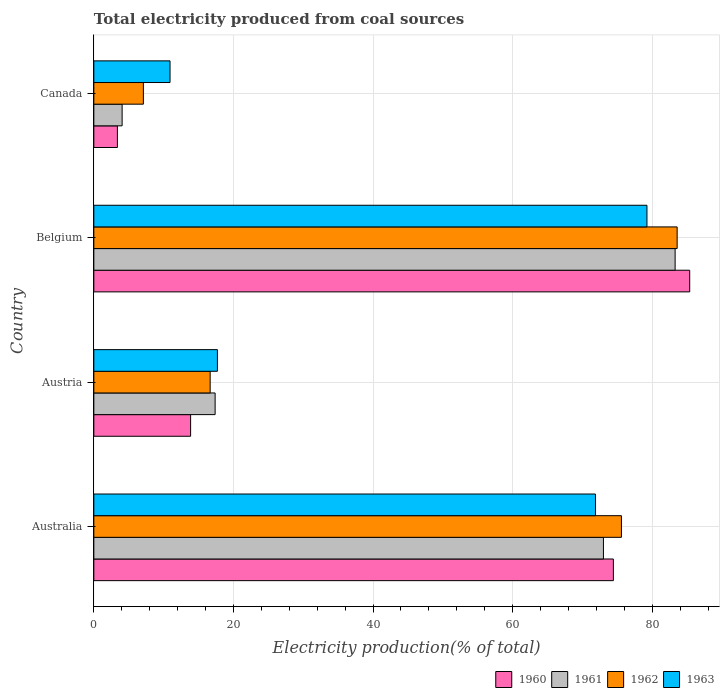How many groups of bars are there?
Your answer should be compact. 4. How many bars are there on the 2nd tick from the bottom?
Offer a very short reply. 4. What is the total electricity produced in 1963 in Australia?
Offer a very short reply. 71.86. Across all countries, what is the maximum total electricity produced in 1961?
Your response must be concise. 83.27. Across all countries, what is the minimum total electricity produced in 1963?
Your response must be concise. 10.92. In which country was the total electricity produced in 1962 minimum?
Keep it short and to the point. Canada. What is the total total electricity produced in 1962 in the graph?
Make the answer very short. 182.9. What is the difference between the total electricity produced in 1961 in Austria and that in Canada?
Provide a succinct answer. 13.32. What is the difference between the total electricity produced in 1963 in Austria and the total electricity produced in 1961 in Canada?
Your answer should be compact. 13.65. What is the average total electricity produced in 1961 per country?
Offer a very short reply. 44.42. What is the difference between the total electricity produced in 1961 and total electricity produced in 1963 in Austria?
Offer a very short reply. -0.33. In how many countries, is the total electricity produced in 1960 greater than 48 %?
Give a very brief answer. 2. What is the ratio of the total electricity produced in 1963 in Belgium to that in Canada?
Ensure brevity in your answer.  7.26. Is the total electricity produced in 1963 in Australia less than that in Canada?
Give a very brief answer. No. Is the difference between the total electricity produced in 1961 in Australia and Canada greater than the difference between the total electricity produced in 1963 in Australia and Canada?
Provide a short and direct response. Yes. What is the difference between the highest and the second highest total electricity produced in 1962?
Offer a terse response. 7.98. What is the difference between the highest and the lowest total electricity produced in 1962?
Provide a succinct answer. 76.46. Is it the case that in every country, the sum of the total electricity produced in 1960 and total electricity produced in 1963 is greater than the sum of total electricity produced in 1961 and total electricity produced in 1962?
Offer a terse response. No. What does the 2nd bar from the top in Australia represents?
Make the answer very short. 1962. What does the 2nd bar from the bottom in Canada represents?
Give a very brief answer. 1961. Is it the case that in every country, the sum of the total electricity produced in 1960 and total electricity produced in 1963 is greater than the total electricity produced in 1961?
Offer a very short reply. Yes. Are all the bars in the graph horizontal?
Offer a terse response. Yes. What is the difference between two consecutive major ticks on the X-axis?
Give a very brief answer. 20. Does the graph contain any zero values?
Your response must be concise. No. Does the graph contain grids?
Provide a succinct answer. Yes. How many legend labels are there?
Ensure brevity in your answer.  4. How are the legend labels stacked?
Provide a short and direct response. Horizontal. What is the title of the graph?
Ensure brevity in your answer.  Total electricity produced from coal sources. Does "2009" appear as one of the legend labels in the graph?
Offer a terse response. No. What is the label or title of the X-axis?
Provide a succinct answer. Electricity production(% of total). What is the label or title of the Y-axis?
Provide a short and direct response. Country. What is the Electricity production(% of total) in 1960 in Australia?
Your answer should be compact. 74.42. What is the Electricity production(% of total) in 1961 in Australia?
Your response must be concise. 73. What is the Electricity production(% of total) of 1962 in Australia?
Your answer should be very brief. 75.58. What is the Electricity production(% of total) of 1963 in Australia?
Ensure brevity in your answer.  71.86. What is the Electricity production(% of total) in 1960 in Austria?
Your answer should be compact. 13.86. What is the Electricity production(% of total) of 1961 in Austria?
Keep it short and to the point. 17.38. What is the Electricity production(% of total) of 1962 in Austria?
Ensure brevity in your answer.  16.66. What is the Electricity production(% of total) in 1963 in Austria?
Make the answer very short. 17.7. What is the Electricity production(% of total) in 1960 in Belgium?
Your response must be concise. 85.36. What is the Electricity production(% of total) in 1961 in Belgium?
Your answer should be compact. 83.27. What is the Electricity production(% of total) of 1962 in Belgium?
Provide a succinct answer. 83.56. What is the Electricity production(% of total) in 1963 in Belgium?
Your answer should be compact. 79.23. What is the Electricity production(% of total) in 1960 in Canada?
Ensure brevity in your answer.  3.38. What is the Electricity production(% of total) of 1961 in Canada?
Provide a succinct answer. 4.05. What is the Electricity production(% of total) in 1962 in Canada?
Your answer should be very brief. 7.1. What is the Electricity production(% of total) of 1963 in Canada?
Offer a terse response. 10.92. Across all countries, what is the maximum Electricity production(% of total) in 1960?
Provide a short and direct response. 85.36. Across all countries, what is the maximum Electricity production(% of total) in 1961?
Provide a succinct answer. 83.27. Across all countries, what is the maximum Electricity production(% of total) in 1962?
Your response must be concise. 83.56. Across all countries, what is the maximum Electricity production(% of total) of 1963?
Make the answer very short. 79.23. Across all countries, what is the minimum Electricity production(% of total) in 1960?
Ensure brevity in your answer.  3.38. Across all countries, what is the minimum Electricity production(% of total) of 1961?
Make the answer very short. 4.05. Across all countries, what is the minimum Electricity production(% of total) of 1962?
Keep it short and to the point. 7.1. Across all countries, what is the minimum Electricity production(% of total) in 1963?
Your answer should be very brief. 10.92. What is the total Electricity production(% of total) in 1960 in the graph?
Give a very brief answer. 177.02. What is the total Electricity production(% of total) in 1961 in the graph?
Your answer should be very brief. 177.7. What is the total Electricity production(% of total) in 1962 in the graph?
Offer a very short reply. 182.9. What is the total Electricity production(% of total) of 1963 in the graph?
Ensure brevity in your answer.  179.71. What is the difference between the Electricity production(% of total) of 1960 in Australia and that in Austria?
Offer a terse response. 60.56. What is the difference between the Electricity production(% of total) of 1961 in Australia and that in Austria?
Keep it short and to the point. 55.62. What is the difference between the Electricity production(% of total) in 1962 in Australia and that in Austria?
Give a very brief answer. 58.91. What is the difference between the Electricity production(% of total) of 1963 in Australia and that in Austria?
Make the answer very short. 54.16. What is the difference between the Electricity production(% of total) in 1960 in Australia and that in Belgium?
Your response must be concise. -10.93. What is the difference between the Electricity production(% of total) of 1961 in Australia and that in Belgium?
Your answer should be very brief. -10.27. What is the difference between the Electricity production(% of total) in 1962 in Australia and that in Belgium?
Ensure brevity in your answer.  -7.98. What is the difference between the Electricity production(% of total) in 1963 in Australia and that in Belgium?
Give a very brief answer. -7.37. What is the difference between the Electricity production(% of total) in 1960 in Australia and that in Canada?
Your response must be concise. 71.05. What is the difference between the Electricity production(% of total) in 1961 in Australia and that in Canada?
Give a very brief answer. 68.94. What is the difference between the Electricity production(% of total) of 1962 in Australia and that in Canada?
Your answer should be very brief. 68.48. What is the difference between the Electricity production(% of total) in 1963 in Australia and that in Canada?
Provide a succinct answer. 60.94. What is the difference between the Electricity production(% of total) of 1960 in Austria and that in Belgium?
Provide a succinct answer. -71.49. What is the difference between the Electricity production(% of total) in 1961 in Austria and that in Belgium?
Offer a very short reply. -65.89. What is the difference between the Electricity production(% of total) in 1962 in Austria and that in Belgium?
Your answer should be very brief. -66.89. What is the difference between the Electricity production(% of total) in 1963 in Austria and that in Belgium?
Offer a terse response. -61.53. What is the difference between the Electricity production(% of total) in 1960 in Austria and that in Canada?
Your answer should be very brief. 10.49. What is the difference between the Electricity production(% of total) of 1961 in Austria and that in Canada?
Provide a succinct answer. 13.32. What is the difference between the Electricity production(% of total) of 1962 in Austria and that in Canada?
Give a very brief answer. 9.57. What is the difference between the Electricity production(% of total) of 1963 in Austria and that in Canada?
Keep it short and to the point. 6.79. What is the difference between the Electricity production(% of total) of 1960 in Belgium and that in Canada?
Your response must be concise. 81.98. What is the difference between the Electricity production(% of total) in 1961 in Belgium and that in Canada?
Offer a very short reply. 79.21. What is the difference between the Electricity production(% of total) of 1962 in Belgium and that in Canada?
Make the answer very short. 76.46. What is the difference between the Electricity production(% of total) in 1963 in Belgium and that in Canada?
Your answer should be very brief. 68.31. What is the difference between the Electricity production(% of total) of 1960 in Australia and the Electricity production(% of total) of 1961 in Austria?
Ensure brevity in your answer.  57.05. What is the difference between the Electricity production(% of total) of 1960 in Australia and the Electricity production(% of total) of 1962 in Austria?
Ensure brevity in your answer.  57.76. What is the difference between the Electricity production(% of total) in 1960 in Australia and the Electricity production(% of total) in 1963 in Austria?
Your answer should be very brief. 56.72. What is the difference between the Electricity production(% of total) of 1961 in Australia and the Electricity production(% of total) of 1962 in Austria?
Your response must be concise. 56.33. What is the difference between the Electricity production(% of total) of 1961 in Australia and the Electricity production(% of total) of 1963 in Austria?
Keep it short and to the point. 55.3. What is the difference between the Electricity production(% of total) in 1962 in Australia and the Electricity production(% of total) in 1963 in Austria?
Give a very brief answer. 57.87. What is the difference between the Electricity production(% of total) in 1960 in Australia and the Electricity production(% of total) in 1961 in Belgium?
Make the answer very short. -8.84. What is the difference between the Electricity production(% of total) in 1960 in Australia and the Electricity production(% of total) in 1962 in Belgium?
Offer a terse response. -9.13. What is the difference between the Electricity production(% of total) in 1960 in Australia and the Electricity production(% of total) in 1963 in Belgium?
Offer a very short reply. -4.81. What is the difference between the Electricity production(% of total) of 1961 in Australia and the Electricity production(% of total) of 1962 in Belgium?
Provide a succinct answer. -10.56. What is the difference between the Electricity production(% of total) in 1961 in Australia and the Electricity production(% of total) in 1963 in Belgium?
Provide a succinct answer. -6.23. What is the difference between the Electricity production(% of total) of 1962 in Australia and the Electricity production(% of total) of 1963 in Belgium?
Give a very brief answer. -3.66. What is the difference between the Electricity production(% of total) in 1960 in Australia and the Electricity production(% of total) in 1961 in Canada?
Give a very brief answer. 70.37. What is the difference between the Electricity production(% of total) of 1960 in Australia and the Electricity production(% of total) of 1962 in Canada?
Provide a succinct answer. 67.32. What is the difference between the Electricity production(% of total) in 1960 in Australia and the Electricity production(% of total) in 1963 in Canada?
Your answer should be very brief. 63.51. What is the difference between the Electricity production(% of total) of 1961 in Australia and the Electricity production(% of total) of 1962 in Canada?
Your answer should be compact. 65.9. What is the difference between the Electricity production(% of total) in 1961 in Australia and the Electricity production(% of total) in 1963 in Canada?
Your answer should be compact. 62.08. What is the difference between the Electricity production(% of total) in 1962 in Australia and the Electricity production(% of total) in 1963 in Canada?
Your answer should be compact. 64.66. What is the difference between the Electricity production(% of total) of 1960 in Austria and the Electricity production(% of total) of 1961 in Belgium?
Provide a short and direct response. -69.4. What is the difference between the Electricity production(% of total) in 1960 in Austria and the Electricity production(% of total) in 1962 in Belgium?
Offer a terse response. -69.69. What is the difference between the Electricity production(% of total) of 1960 in Austria and the Electricity production(% of total) of 1963 in Belgium?
Provide a succinct answer. -65.37. What is the difference between the Electricity production(% of total) in 1961 in Austria and the Electricity production(% of total) in 1962 in Belgium?
Make the answer very short. -66.18. What is the difference between the Electricity production(% of total) of 1961 in Austria and the Electricity production(% of total) of 1963 in Belgium?
Keep it short and to the point. -61.86. What is the difference between the Electricity production(% of total) in 1962 in Austria and the Electricity production(% of total) in 1963 in Belgium?
Offer a terse response. -62.57. What is the difference between the Electricity production(% of total) of 1960 in Austria and the Electricity production(% of total) of 1961 in Canada?
Your answer should be very brief. 9.81. What is the difference between the Electricity production(% of total) in 1960 in Austria and the Electricity production(% of total) in 1962 in Canada?
Your response must be concise. 6.77. What is the difference between the Electricity production(% of total) in 1960 in Austria and the Electricity production(% of total) in 1963 in Canada?
Ensure brevity in your answer.  2.95. What is the difference between the Electricity production(% of total) of 1961 in Austria and the Electricity production(% of total) of 1962 in Canada?
Keep it short and to the point. 10.28. What is the difference between the Electricity production(% of total) in 1961 in Austria and the Electricity production(% of total) in 1963 in Canada?
Offer a terse response. 6.46. What is the difference between the Electricity production(% of total) of 1962 in Austria and the Electricity production(% of total) of 1963 in Canada?
Make the answer very short. 5.75. What is the difference between the Electricity production(% of total) of 1960 in Belgium and the Electricity production(% of total) of 1961 in Canada?
Make the answer very short. 81.3. What is the difference between the Electricity production(% of total) of 1960 in Belgium and the Electricity production(% of total) of 1962 in Canada?
Your answer should be compact. 78.26. What is the difference between the Electricity production(% of total) of 1960 in Belgium and the Electricity production(% of total) of 1963 in Canada?
Your answer should be compact. 74.44. What is the difference between the Electricity production(% of total) of 1961 in Belgium and the Electricity production(% of total) of 1962 in Canada?
Your answer should be compact. 76.17. What is the difference between the Electricity production(% of total) of 1961 in Belgium and the Electricity production(% of total) of 1963 in Canada?
Provide a short and direct response. 72.35. What is the difference between the Electricity production(% of total) in 1962 in Belgium and the Electricity production(% of total) in 1963 in Canada?
Your response must be concise. 72.64. What is the average Electricity production(% of total) of 1960 per country?
Provide a short and direct response. 44.26. What is the average Electricity production(% of total) in 1961 per country?
Provide a short and direct response. 44.42. What is the average Electricity production(% of total) in 1962 per country?
Provide a short and direct response. 45.72. What is the average Electricity production(% of total) in 1963 per country?
Provide a succinct answer. 44.93. What is the difference between the Electricity production(% of total) in 1960 and Electricity production(% of total) in 1961 in Australia?
Offer a very short reply. 1.42. What is the difference between the Electricity production(% of total) of 1960 and Electricity production(% of total) of 1962 in Australia?
Keep it short and to the point. -1.15. What is the difference between the Electricity production(% of total) in 1960 and Electricity production(% of total) in 1963 in Australia?
Give a very brief answer. 2.57. What is the difference between the Electricity production(% of total) of 1961 and Electricity production(% of total) of 1962 in Australia?
Offer a terse response. -2.58. What is the difference between the Electricity production(% of total) in 1961 and Electricity production(% of total) in 1963 in Australia?
Give a very brief answer. 1.14. What is the difference between the Electricity production(% of total) of 1962 and Electricity production(% of total) of 1963 in Australia?
Your answer should be very brief. 3.72. What is the difference between the Electricity production(% of total) in 1960 and Electricity production(% of total) in 1961 in Austria?
Provide a succinct answer. -3.51. What is the difference between the Electricity production(% of total) of 1960 and Electricity production(% of total) of 1963 in Austria?
Keep it short and to the point. -3.84. What is the difference between the Electricity production(% of total) in 1961 and Electricity production(% of total) in 1962 in Austria?
Offer a terse response. 0.71. What is the difference between the Electricity production(% of total) of 1961 and Electricity production(% of total) of 1963 in Austria?
Offer a terse response. -0.33. What is the difference between the Electricity production(% of total) in 1962 and Electricity production(% of total) in 1963 in Austria?
Your response must be concise. -1.04. What is the difference between the Electricity production(% of total) in 1960 and Electricity production(% of total) in 1961 in Belgium?
Make the answer very short. 2.09. What is the difference between the Electricity production(% of total) of 1960 and Electricity production(% of total) of 1962 in Belgium?
Offer a very short reply. 1.8. What is the difference between the Electricity production(% of total) in 1960 and Electricity production(% of total) in 1963 in Belgium?
Keep it short and to the point. 6.12. What is the difference between the Electricity production(% of total) in 1961 and Electricity production(% of total) in 1962 in Belgium?
Your response must be concise. -0.29. What is the difference between the Electricity production(% of total) of 1961 and Electricity production(% of total) of 1963 in Belgium?
Your answer should be very brief. 4.04. What is the difference between the Electricity production(% of total) of 1962 and Electricity production(% of total) of 1963 in Belgium?
Your answer should be very brief. 4.33. What is the difference between the Electricity production(% of total) in 1960 and Electricity production(% of total) in 1961 in Canada?
Give a very brief answer. -0.68. What is the difference between the Electricity production(% of total) of 1960 and Electricity production(% of total) of 1962 in Canada?
Your response must be concise. -3.72. What is the difference between the Electricity production(% of total) of 1960 and Electricity production(% of total) of 1963 in Canada?
Keep it short and to the point. -7.54. What is the difference between the Electricity production(% of total) of 1961 and Electricity production(% of total) of 1962 in Canada?
Provide a short and direct response. -3.04. What is the difference between the Electricity production(% of total) in 1961 and Electricity production(% of total) in 1963 in Canada?
Provide a succinct answer. -6.86. What is the difference between the Electricity production(% of total) of 1962 and Electricity production(% of total) of 1963 in Canada?
Make the answer very short. -3.82. What is the ratio of the Electricity production(% of total) of 1960 in Australia to that in Austria?
Ensure brevity in your answer.  5.37. What is the ratio of the Electricity production(% of total) of 1961 in Australia to that in Austria?
Provide a succinct answer. 4.2. What is the ratio of the Electricity production(% of total) of 1962 in Australia to that in Austria?
Offer a terse response. 4.54. What is the ratio of the Electricity production(% of total) of 1963 in Australia to that in Austria?
Your answer should be compact. 4.06. What is the ratio of the Electricity production(% of total) in 1960 in Australia to that in Belgium?
Your answer should be compact. 0.87. What is the ratio of the Electricity production(% of total) of 1961 in Australia to that in Belgium?
Your response must be concise. 0.88. What is the ratio of the Electricity production(% of total) in 1962 in Australia to that in Belgium?
Ensure brevity in your answer.  0.9. What is the ratio of the Electricity production(% of total) of 1963 in Australia to that in Belgium?
Keep it short and to the point. 0.91. What is the ratio of the Electricity production(% of total) in 1960 in Australia to that in Canada?
Your response must be concise. 22.03. What is the ratio of the Electricity production(% of total) of 1961 in Australia to that in Canada?
Offer a very short reply. 18.01. What is the ratio of the Electricity production(% of total) in 1962 in Australia to that in Canada?
Provide a succinct answer. 10.65. What is the ratio of the Electricity production(% of total) in 1963 in Australia to that in Canada?
Keep it short and to the point. 6.58. What is the ratio of the Electricity production(% of total) of 1960 in Austria to that in Belgium?
Ensure brevity in your answer.  0.16. What is the ratio of the Electricity production(% of total) in 1961 in Austria to that in Belgium?
Make the answer very short. 0.21. What is the ratio of the Electricity production(% of total) of 1962 in Austria to that in Belgium?
Provide a succinct answer. 0.2. What is the ratio of the Electricity production(% of total) of 1963 in Austria to that in Belgium?
Ensure brevity in your answer.  0.22. What is the ratio of the Electricity production(% of total) of 1960 in Austria to that in Canada?
Your answer should be compact. 4.1. What is the ratio of the Electricity production(% of total) in 1961 in Austria to that in Canada?
Your answer should be very brief. 4.29. What is the ratio of the Electricity production(% of total) in 1962 in Austria to that in Canada?
Ensure brevity in your answer.  2.35. What is the ratio of the Electricity production(% of total) of 1963 in Austria to that in Canada?
Give a very brief answer. 1.62. What is the ratio of the Electricity production(% of total) in 1960 in Belgium to that in Canada?
Offer a very short reply. 25.27. What is the ratio of the Electricity production(% of total) in 1961 in Belgium to that in Canada?
Ensure brevity in your answer.  20.54. What is the ratio of the Electricity production(% of total) of 1962 in Belgium to that in Canada?
Your answer should be compact. 11.77. What is the ratio of the Electricity production(% of total) in 1963 in Belgium to that in Canada?
Your answer should be compact. 7.26. What is the difference between the highest and the second highest Electricity production(% of total) in 1960?
Keep it short and to the point. 10.93. What is the difference between the highest and the second highest Electricity production(% of total) in 1961?
Provide a short and direct response. 10.27. What is the difference between the highest and the second highest Electricity production(% of total) of 1962?
Offer a terse response. 7.98. What is the difference between the highest and the second highest Electricity production(% of total) in 1963?
Your answer should be compact. 7.37. What is the difference between the highest and the lowest Electricity production(% of total) of 1960?
Your answer should be compact. 81.98. What is the difference between the highest and the lowest Electricity production(% of total) of 1961?
Provide a succinct answer. 79.21. What is the difference between the highest and the lowest Electricity production(% of total) of 1962?
Your answer should be compact. 76.46. What is the difference between the highest and the lowest Electricity production(% of total) of 1963?
Your answer should be very brief. 68.31. 